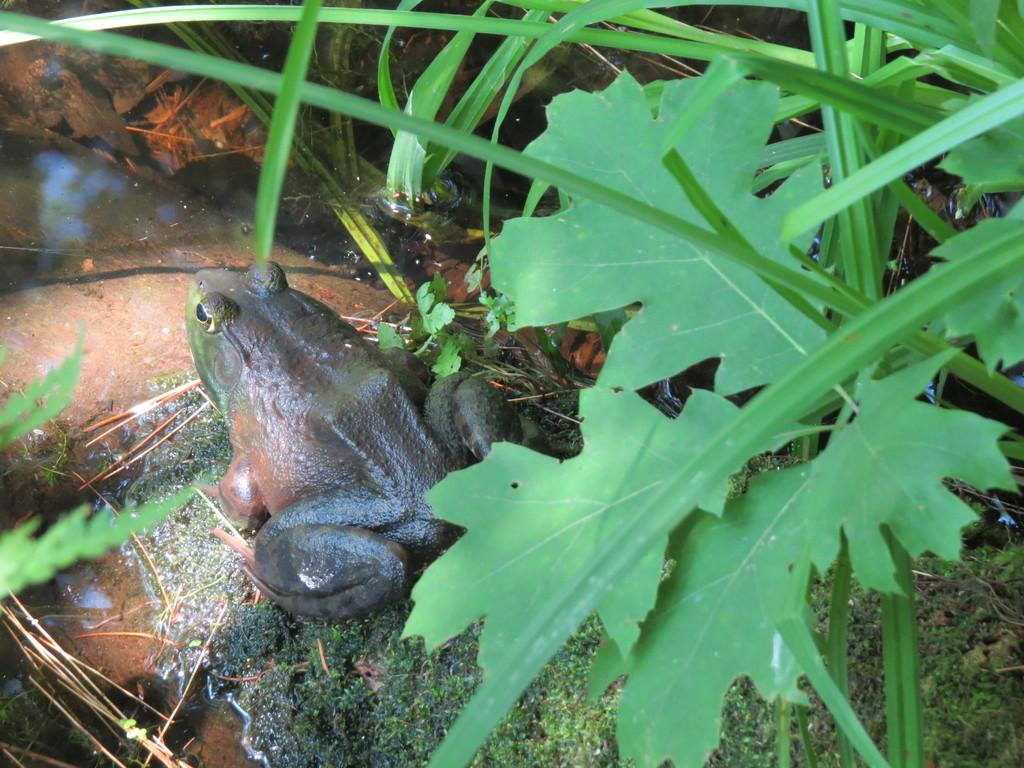What type of animal is in the image? There is a frog in the image. What type of vegetation is present in the image? There are leaves and grass visible in the image. What is the water feature in the image? There is water visible in the image. What type of religious symbol can be seen in the image? There is no religious symbol present in the image; it features a frog, leaves, grass, and water. How many hills are visible in the image? There are no hills visible in the image. 